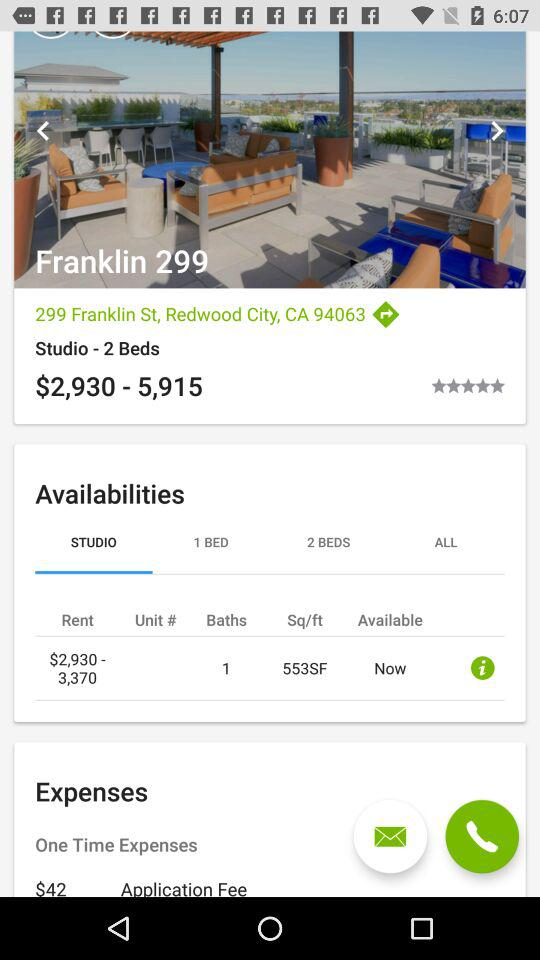How many baths are there in the "STUDIO"? There is one bath in the "STUDIO". 